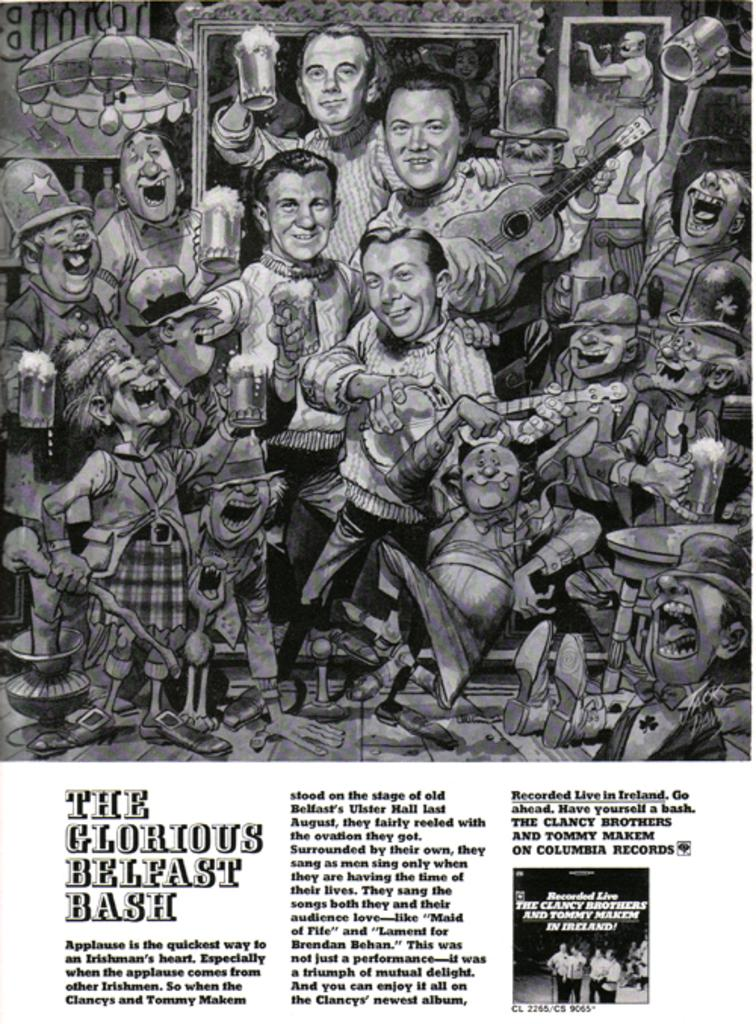What is featured in the image? There is a poster in the image. What can be seen on the poster? The poster contains people. Can you describe the actions of the people on the poster? One person in the poster is holding a guitar. What type of butter is being used by the person holding the guitar on the poster? There is no butter present in the image, as it features a poster with people, one of whom is holding a guitar. 